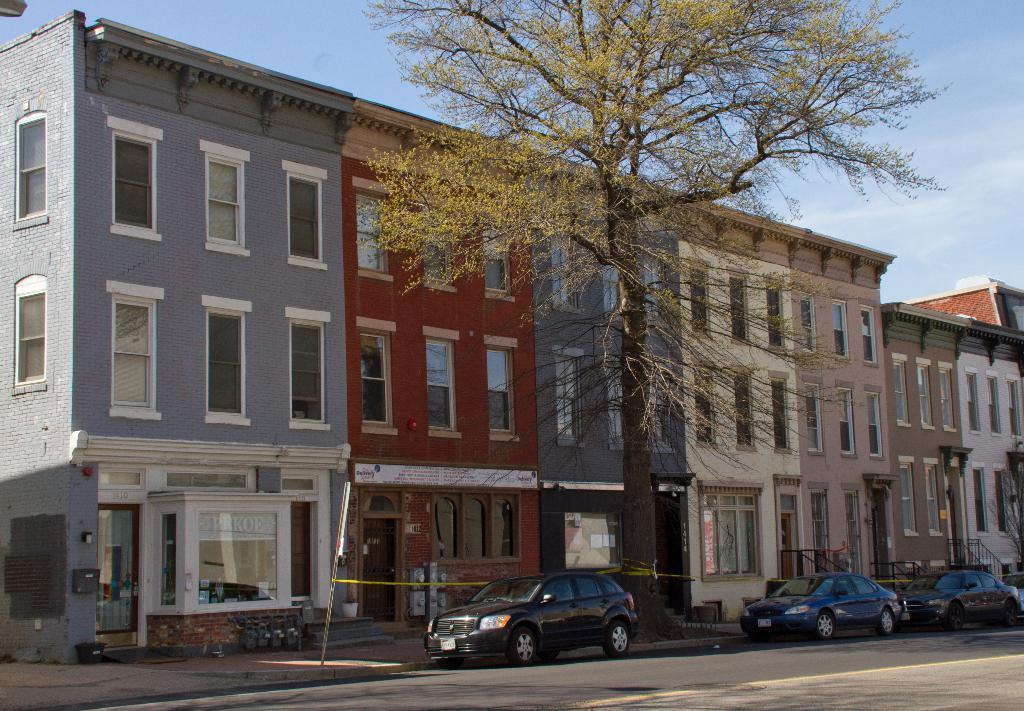What type of vehicles can be seen on the road in the image? There are cars on the road in the image. What color are the cars? The cars are black. What can be seen in the background of the image? There are trees, buildings, and the sky visible in the background of the image. What is the color of the trees? The trees are green. What colors can be seen on the buildings in the background? The buildings have various colors, including gray, red, and brown. What is visible in the sky in the background of the image? The sky is blue. Can you see any spots on the sidewalk in the image? There is no sidewalk present in the image. How many feet are visible on the road in the image? There are no feet visible in the image; only cars are present on the road. 